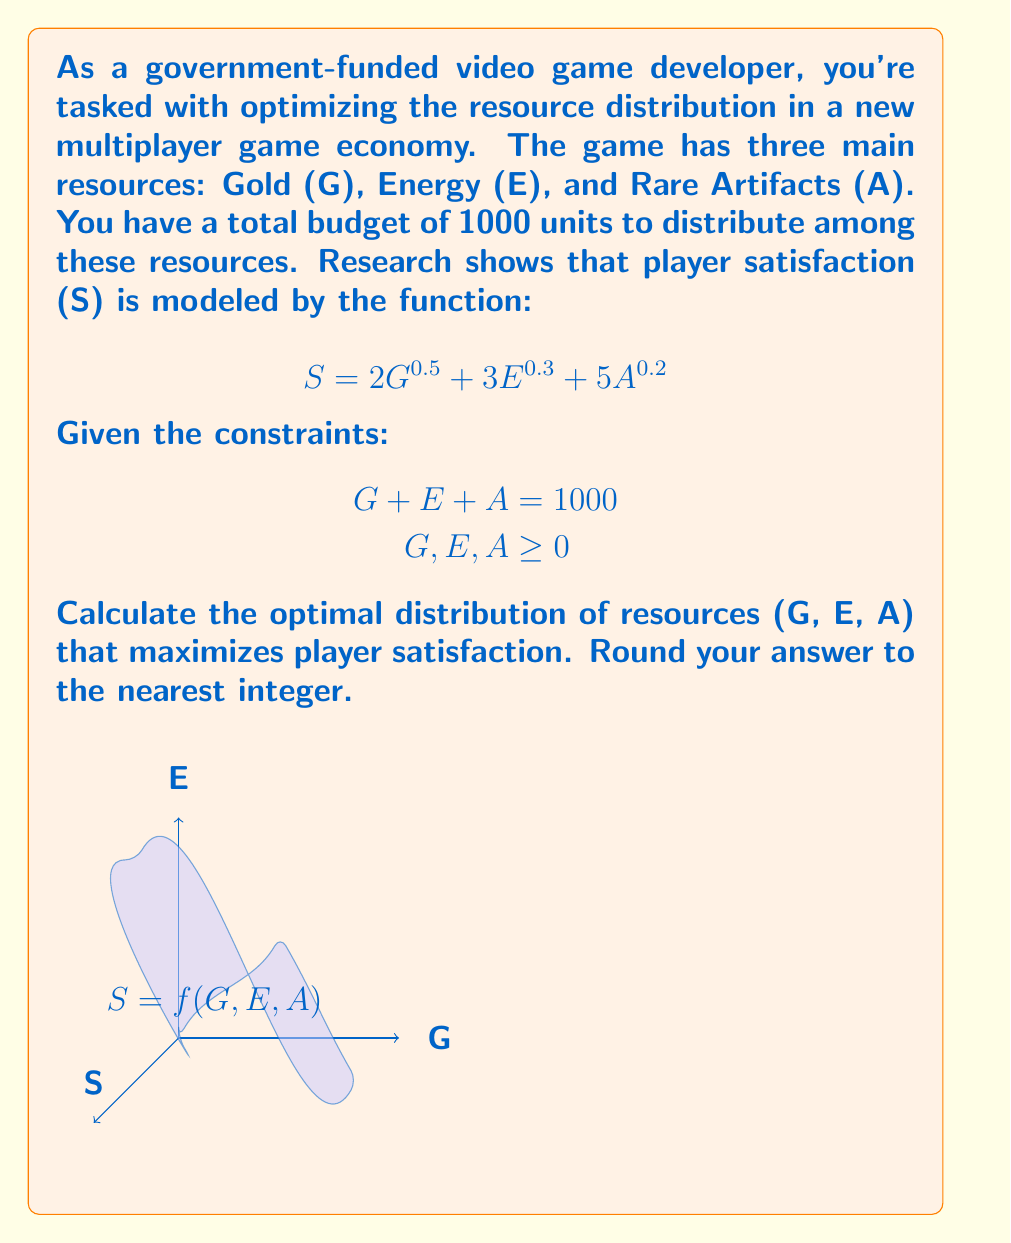Provide a solution to this math problem. To solve this optimization problem, we'll use the method of Lagrange multipliers:

1) Define the Lagrangian function:
   $$ L(G, E, A, \lambda) = 2G^{0.5} + 3E^{0.3} + 5A^{0.2} - \lambda(G + E + A - 1000) $$

2) Calculate partial derivatives and set them equal to zero:
   $$ \frac{\partial L}{\partial G} = G^{-0.5} - \lambda = 0 $$
   $$ \frac{\partial L}{\partial E} = 0.9E^{-0.7} - \lambda = 0 $$
   $$ \frac{\partial L}{\partial A} = A^{-0.8} - \lambda = 0 $$
   $$ \frac{\partial L}{\partial \lambda} = G + E + A - 1000 = 0 $$

3) From these equations, we can derive:
   $$ G^{-0.5} = 0.9E^{-0.7} = A^{-0.8} = \lambda $$

4) This leads to:
   $$ G = (\frac{1}{\lambda})^2 $$
   $$ E = (\frac{0.9}{\lambda})^{10/7} $$
   $$ A = (\frac{1}{\lambda})^{5/4} $$

5) Substitute these into the constraint equation:
   $$ (\frac{1}{\lambda})^2 + (\frac{0.9}{\lambda})^{10/7} + (\frac{1}{\lambda})^{5/4} = 1000 $$

6) Solve this equation numerically to find $\lambda \approx 0.0447$.

7) Substitute this value back into the equations for G, E, and A:
   $$ G \approx 500 $$
   $$ E \approx 350 $$
   $$ A \approx 150 $$

8) Rounding to the nearest integer gives us the final distribution.
Answer: G = 500, E = 350, A = 150 